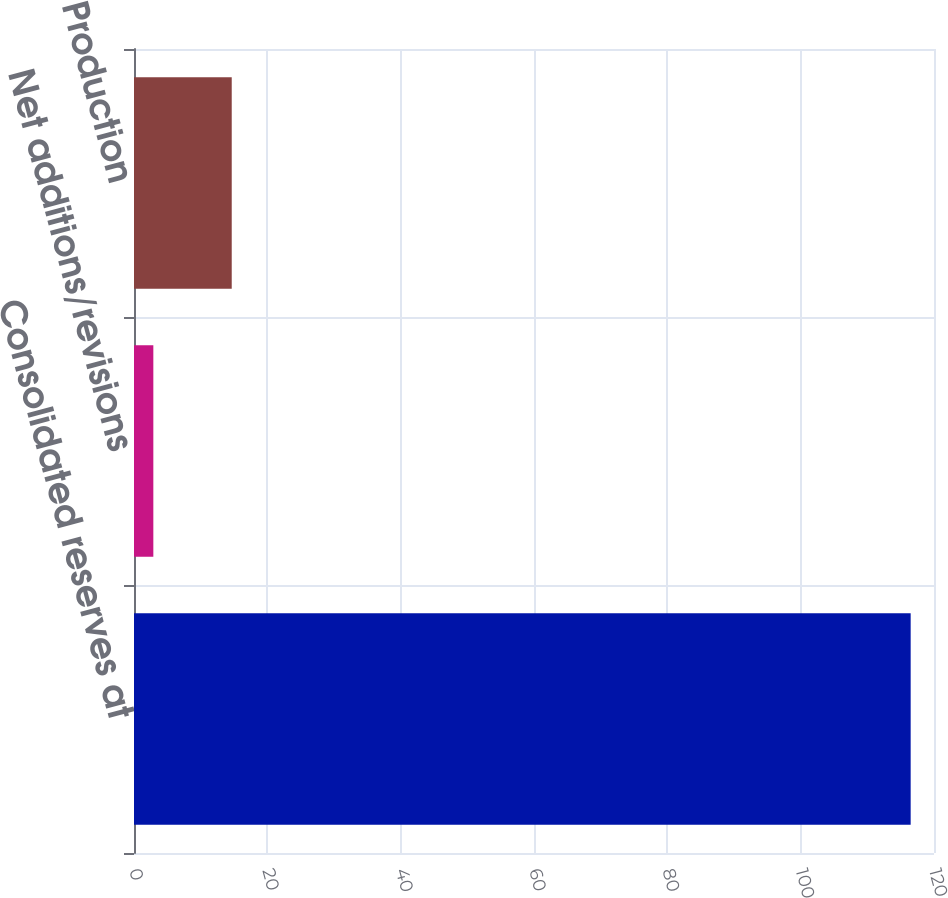Convert chart. <chart><loc_0><loc_0><loc_500><loc_500><bar_chart><fcel>Consolidated reserves at<fcel>Net additions/revisions<fcel>Production<nl><fcel>116.5<fcel>2.9<fcel>14.66<nl></chart> 